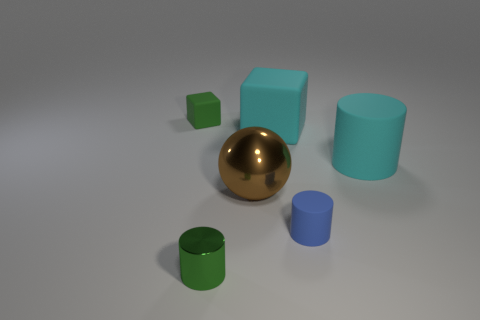Are there fewer objects in front of the green matte thing than things?
Ensure brevity in your answer.  Yes. What number of objects are either small rubber things or matte cylinders that are right of the small rubber cylinder?
Offer a terse response. 3. There is a cylinder that is made of the same material as the large brown ball; what is its color?
Offer a terse response. Green. How many objects are tiny metal objects or tiny objects?
Offer a very short reply. 3. There is a shiny thing that is the same size as the blue cylinder; what is its color?
Your answer should be compact. Green. What number of things are objects in front of the green rubber cube or green cylinders?
Ensure brevity in your answer.  5. How many other objects are there of the same size as the metal sphere?
Provide a succinct answer. 2. What is the size of the green thing in front of the tiny green matte thing?
Provide a succinct answer. Small. There is a object that is made of the same material as the big ball; what shape is it?
Your answer should be very brief. Cylinder. Is there anything else of the same color as the tiny matte cylinder?
Your answer should be compact. No. 